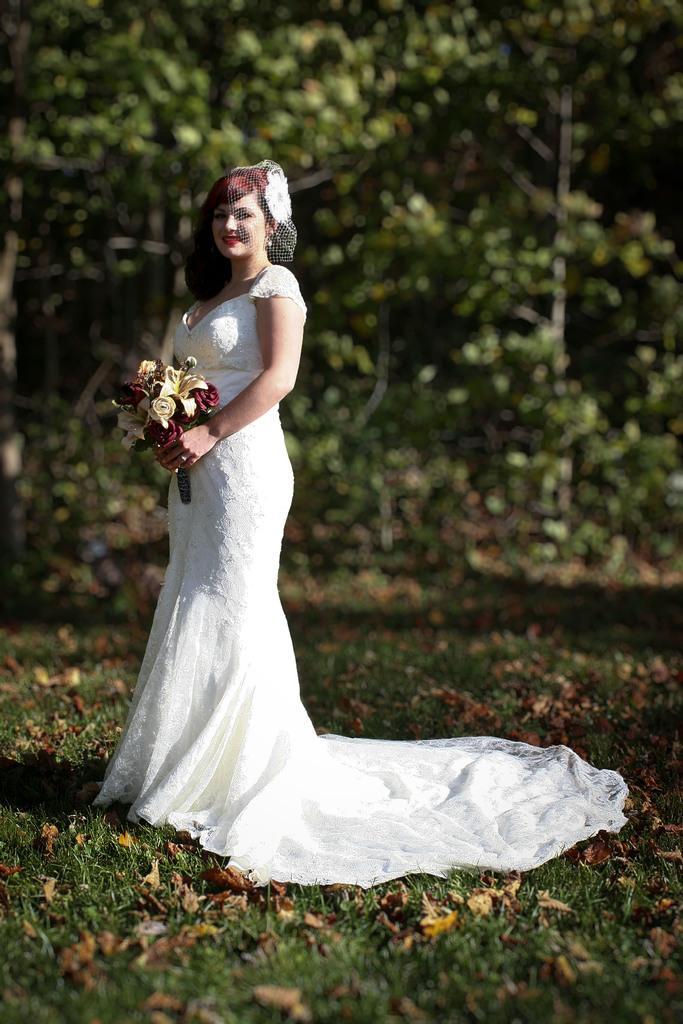How would you summarize this image in a sentence or two? In this picture I can see a woman wearing a wedding dress and holding flower bouquet. I can see the green grass. I can see trees. 